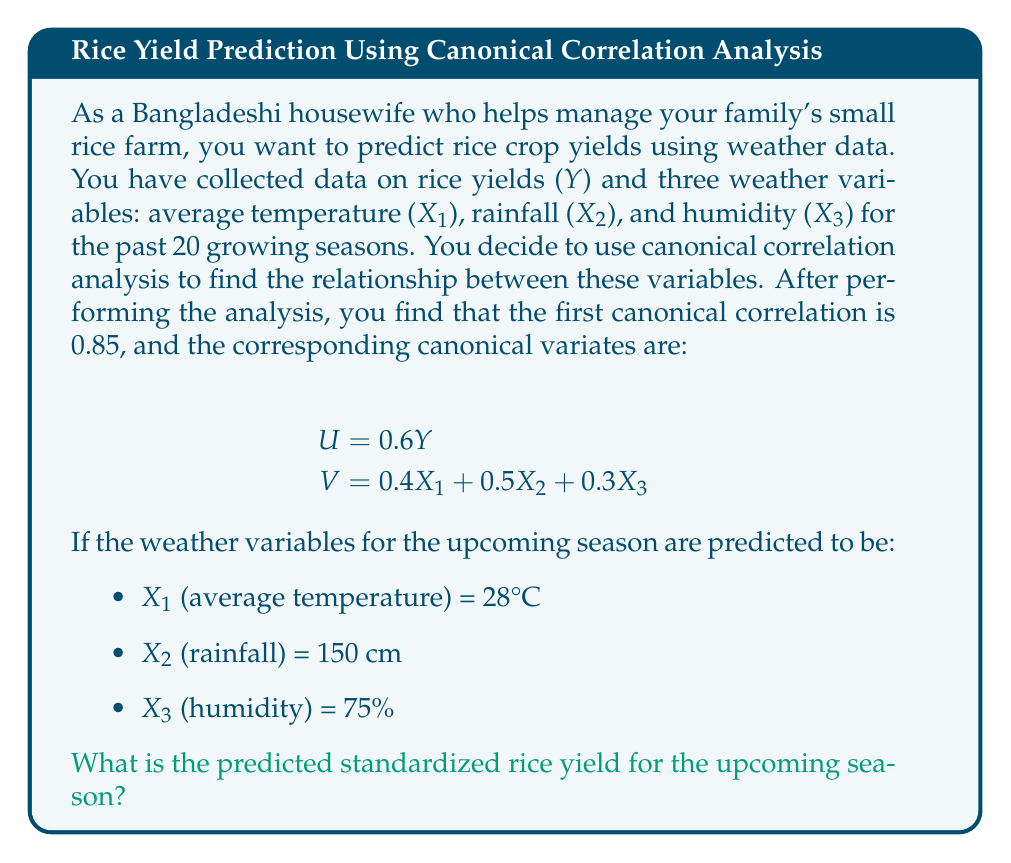What is the answer to this math problem? Let's approach this step-by-step:

1) First, we need to understand what the canonical variates represent:
   U = 0.6Y (for yield)
   V = 0.4X1 + 0.5X2 + 0.3X3 (for weather variables)

2) The canonical correlation (0.85) represents the correlation between U and V. In other words:

   $$\text{Corr}(U, V) = 0.85$$

3) Given that correlation is symmetric, we can write:

   $$U = 0.85V$$

4) Now, let's substitute the values for the weather variables into V:

   $$V = 0.4(28) + 0.5(150) + 0.3(75)$$
   $$V = 11.2 + 75 + 22.5 = 108.7$$

5) Now we can find U:

   $$U = 0.85V = 0.85(108.7) = 92.395$$

6) Remember that U = 0.6Y. So we can solve for Y:

   $$0.6Y = 92.395$$
   $$Y = 92.395 / 0.6 = 153.99$$

7) This Y represents the standardized rice yield for the upcoming season.
Answer: 153.99 